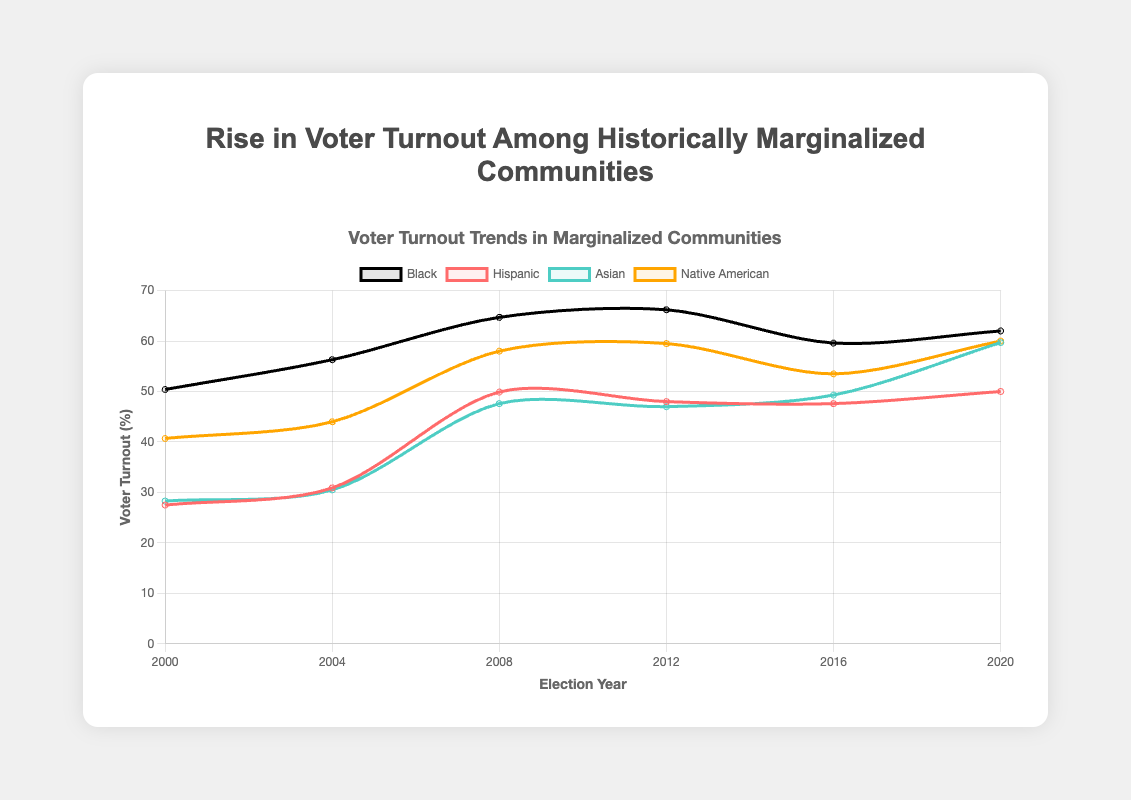What is the voter turnout percentage for Black voters in 2008? In the year 2008, the voter turnout percentage for Black voters is directly given in the chart's data points.
Answer: 64.7% Which ethnic group had the highest voter turnout in 2020? By looking at the lines for each ethnic group, we observe that Native American voters had the highest voter turnout in 2020.
Answer: Native American Between 2000 and 2020, which group's voter turnout increased the most? We calculate the increase for each group over the 20-year period by subtracting the 2000 turnout from the 2020 turnout. The largest increase is for the Asian population: 
- Black: 62.0 - 50.4 = 11.6
- Hispanic: 50.0 - 27.5 = 22.5
- Asian: 59.7 - 28.3 = 31.4
- Native American: 60.0 - 40.7 = 19.3
Answer: Asian Which year had equal or nearly equal voter turnout rates for Hispanic and Native American voters? By scanning the lines, we find that the turnouts are very nearly the same in the year 2004; Hispanic (30.9%) and Native American (44.0%). They are closest in 2016; Hispanic (47.6%) and Native American (53.5%).
Answer: 2016 What is the average voter turnout for Asian voters from 2000 to 2020? Add the turnout percentages for Asian voters for each year and divide by the number of years: 
(28.3 + 30.5 + 47.6 + 47.0 + 49.3 + 59.7) / 6 = 43.7
Answer: 43.7 Did any group experience a drop in voter turnout between 2012 and 2016? By checking the data points, the Black voter turnout decreased from 66.2% in 2012 to 59.6% in 2016.
Answer: Yes How many times did the Black voter turnout increase from one election year to the next? By analyzing the trends, we see increases from 2000-2004, 2004-2008, 2008-2012, and 2016-2020. There are four increases.
Answer: Four In which election year was the voter turnout for the Hispanic group closest in value to the Asian group? We observe the lines intersected in 2020 where Hispanic had a 50% turnout and Asian had a slightly higher 59.7% turnout, making them close.
Answer: 2020 Compare the voter turnout of Native American voters from 2008 to 2016 with Black voters from 2008 to 2012. Which group had a larger increase in voter turnout? Calculate the changes:
- Native American from 2008 to 2016: 53.5 - 58.0 = -4.5
- Black from 2008 to 2012: 66.2 - 64.7 = 1.5
Answer: Black Which group improved their voter turnout the least from 2000 to 2020? Calculate the change for each group and find the smallest increase:
- Black: 62.0 - 50.4 = 11.6
- Hispanic: 50.0 - 27.5 = 22.5
- Asian: 59.7 - 28.3 = 31.4
- Native American: 60.0 - 40.7 = 19.3
Answer: Black 